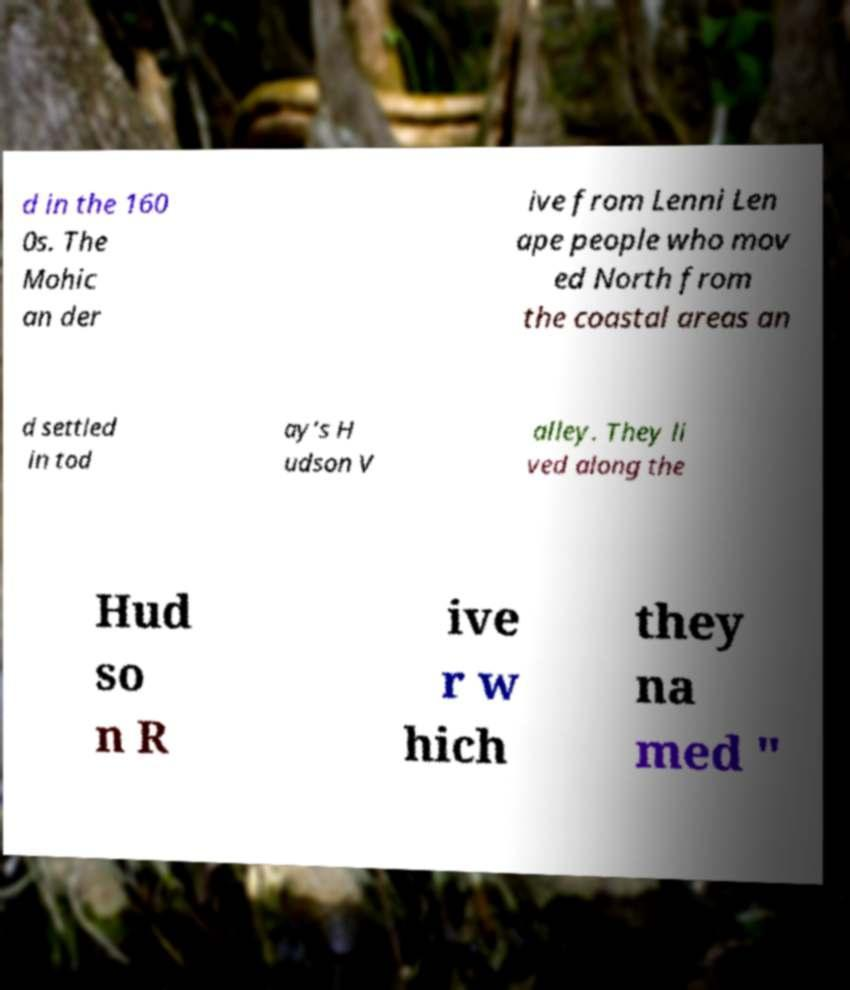There's text embedded in this image that I need extracted. Can you transcribe it verbatim? d in the 160 0s. The Mohic an der ive from Lenni Len ape people who mov ed North from the coastal areas an d settled in tod ay’s H udson V alley. They li ved along the Hud so n R ive r w hich they na med " 